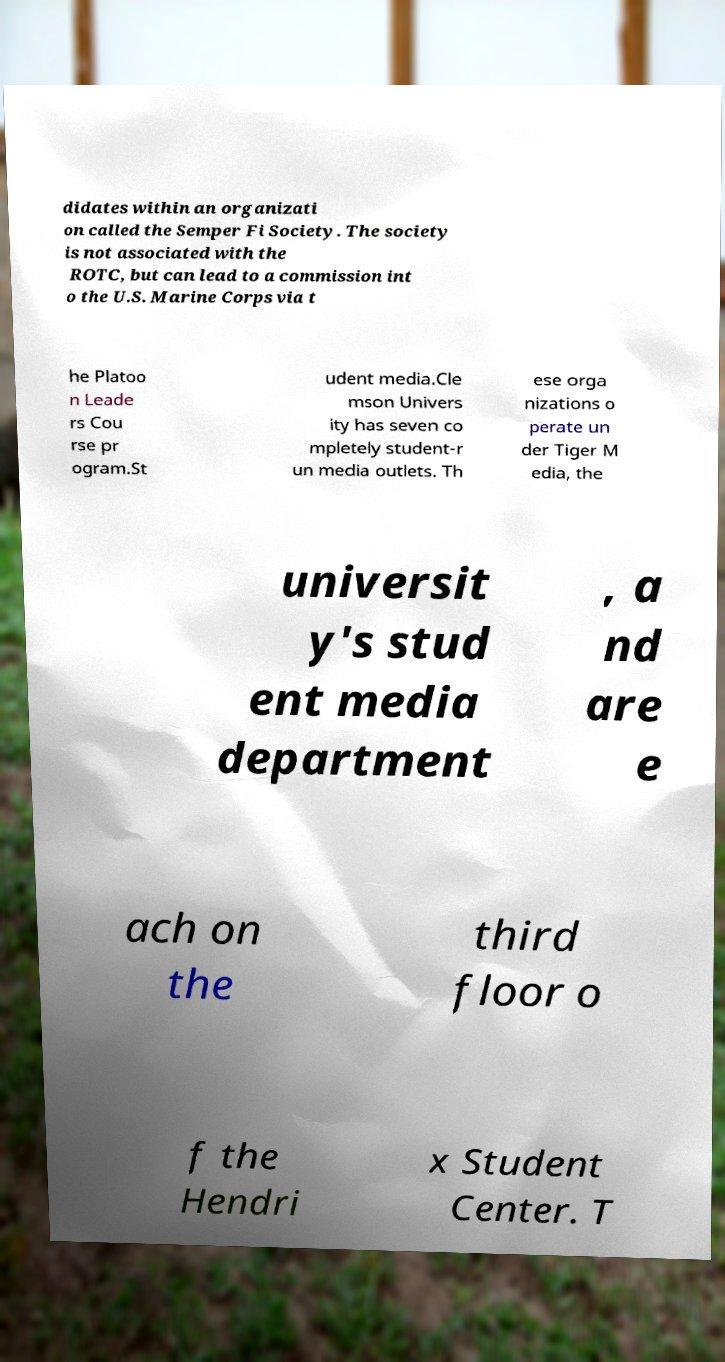Could you extract and type out the text from this image? didates within an organizati on called the Semper Fi Society. The society is not associated with the ROTC, but can lead to a commission int o the U.S. Marine Corps via t he Platoo n Leade rs Cou rse pr ogram.St udent media.Cle mson Univers ity has seven co mpletely student-r un media outlets. Th ese orga nizations o perate un der Tiger M edia, the universit y's stud ent media department , a nd are e ach on the third floor o f the Hendri x Student Center. T 